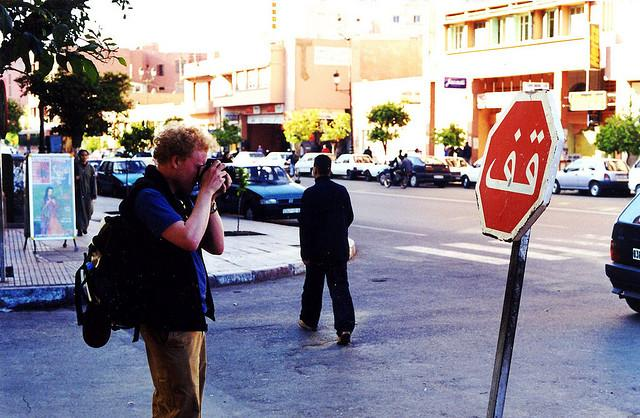What country is this? Please explain your reasoning. india. India is showed due to the language on the stop sign. 